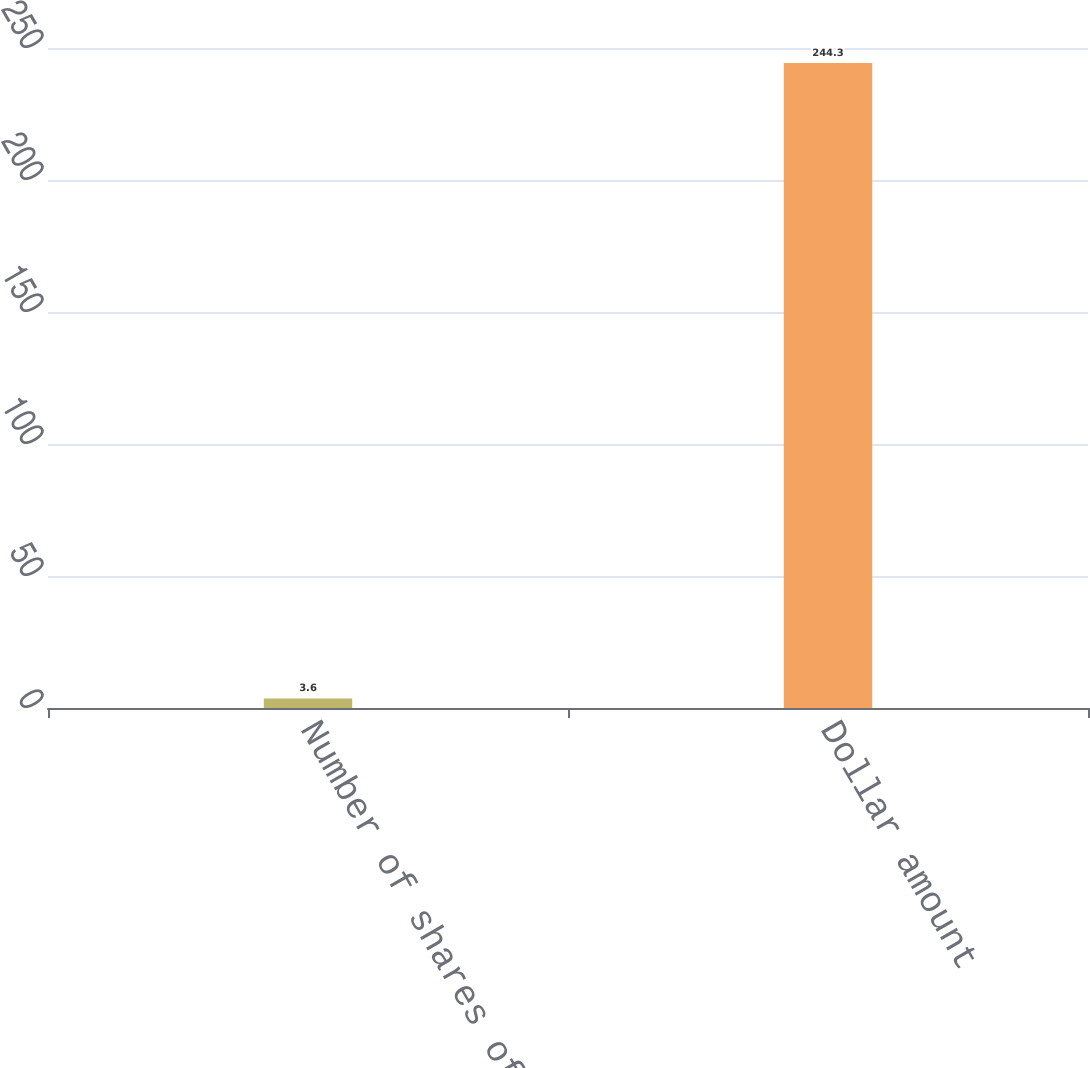<chart> <loc_0><loc_0><loc_500><loc_500><bar_chart><fcel>Number of shares of common<fcel>Dollar amount<nl><fcel>3.6<fcel>244.3<nl></chart> 